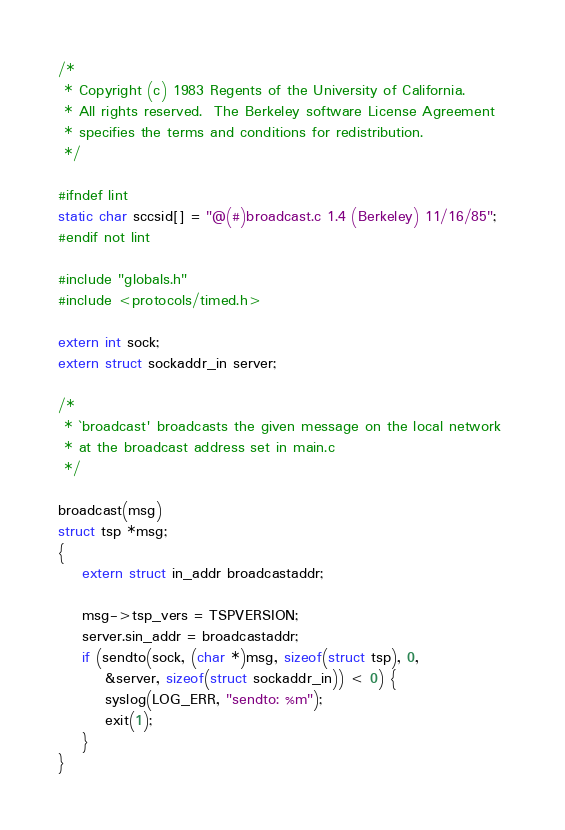Convert code to text. <code><loc_0><loc_0><loc_500><loc_500><_C_>/*
 * Copyright (c) 1983 Regents of the University of California.
 * All rights reserved.  The Berkeley software License Agreement
 * specifies the terms and conditions for redistribution.
 */

#ifndef lint
static char sccsid[] = "@(#)broadcast.c	1.4 (Berkeley) 11/16/85";
#endif not lint

#include "globals.h"
#include <protocols/timed.h>

extern int sock;
extern struct sockaddr_in server;

/* 
 * `broadcast' broadcasts the given message on the local network 
 * at the broadcast address set in main.c
 */

broadcast(msg) 
struct tsp *msg;
{
	extern struct in_addr broadcastaddr;

	msg->tsp_vers = TSPVERSION;
	server.sin_addr = broadcastaddr;
	if (sendto(sock, (char *)msg, sizeof(struct tsp), 0, 
	    &server, sizeof(struct sockaddr_in)) < 0) {
		syslog(LOG_ERR, "sendto: %m");
		exit(1);
	}
}
</code> 